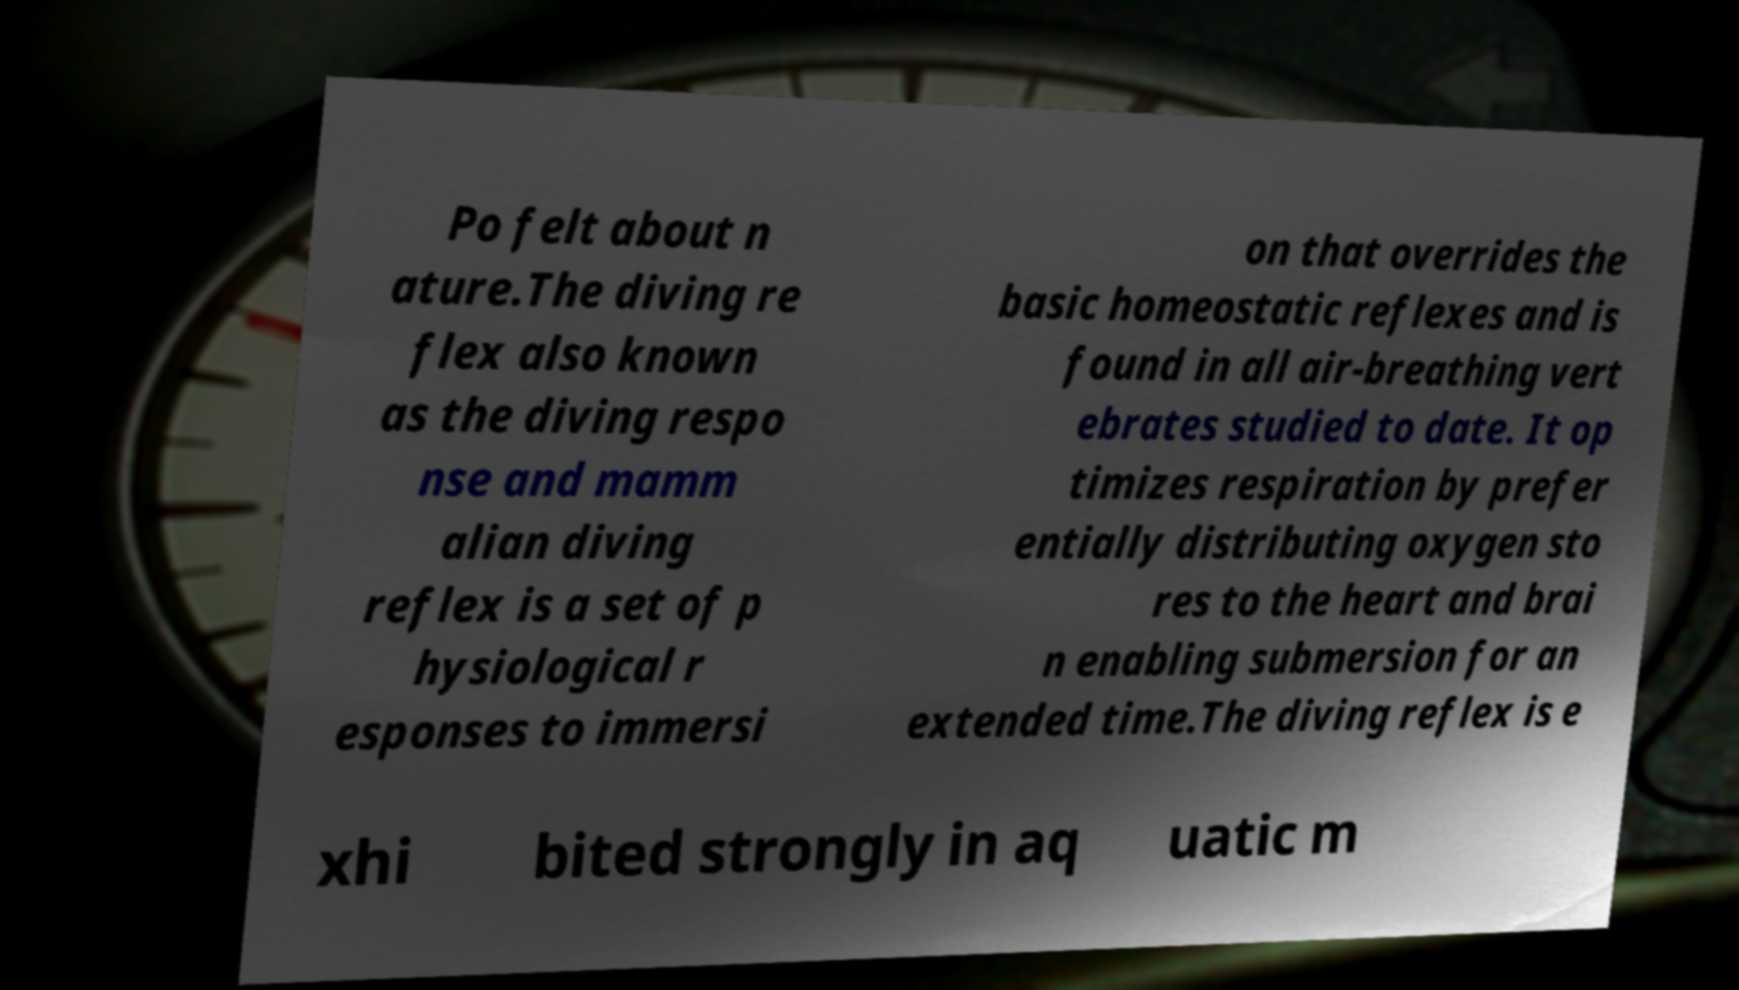Please read and relay the text visible in this image. What does it say? Po felt about n ature.The diving re flex also known as the diving respo nse and mamm alian diving reflex is a set of p hysiological r esponses to immersi on that overrides the basic homeostatic reflexes and is found in all air-breathing vert ebrates studied to date. It op timizes respiration by prefer entially distributing oxygen sto res to the heart and brai n enabling submersion for an extended time.The diving reflex is e xhi bited strongly in aq uatic m 